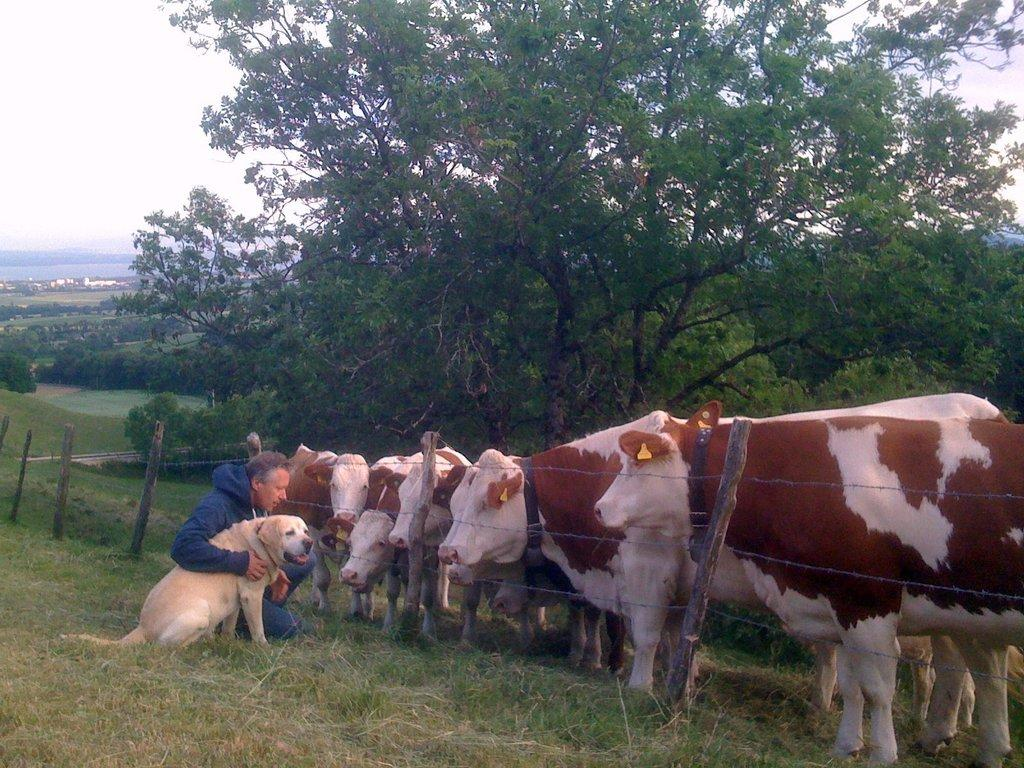What type of animals are present in the image? There are cows in the image. What other living creature can be seen in the image? There is a dog in the image. Is there a person in the image? Yes, there is a man in the image. What is separating the animals and the man in the image? There is a fence in the image. What can be seen in the background of the image? There are trees and grass in the background of the image. What type of knife is the man using to share his knowledge with the cows in the image? There is no knife or knowledge sharing activity present in the image. The man, cows, and dog are simply coexisting in the same space, separated by a fence. 